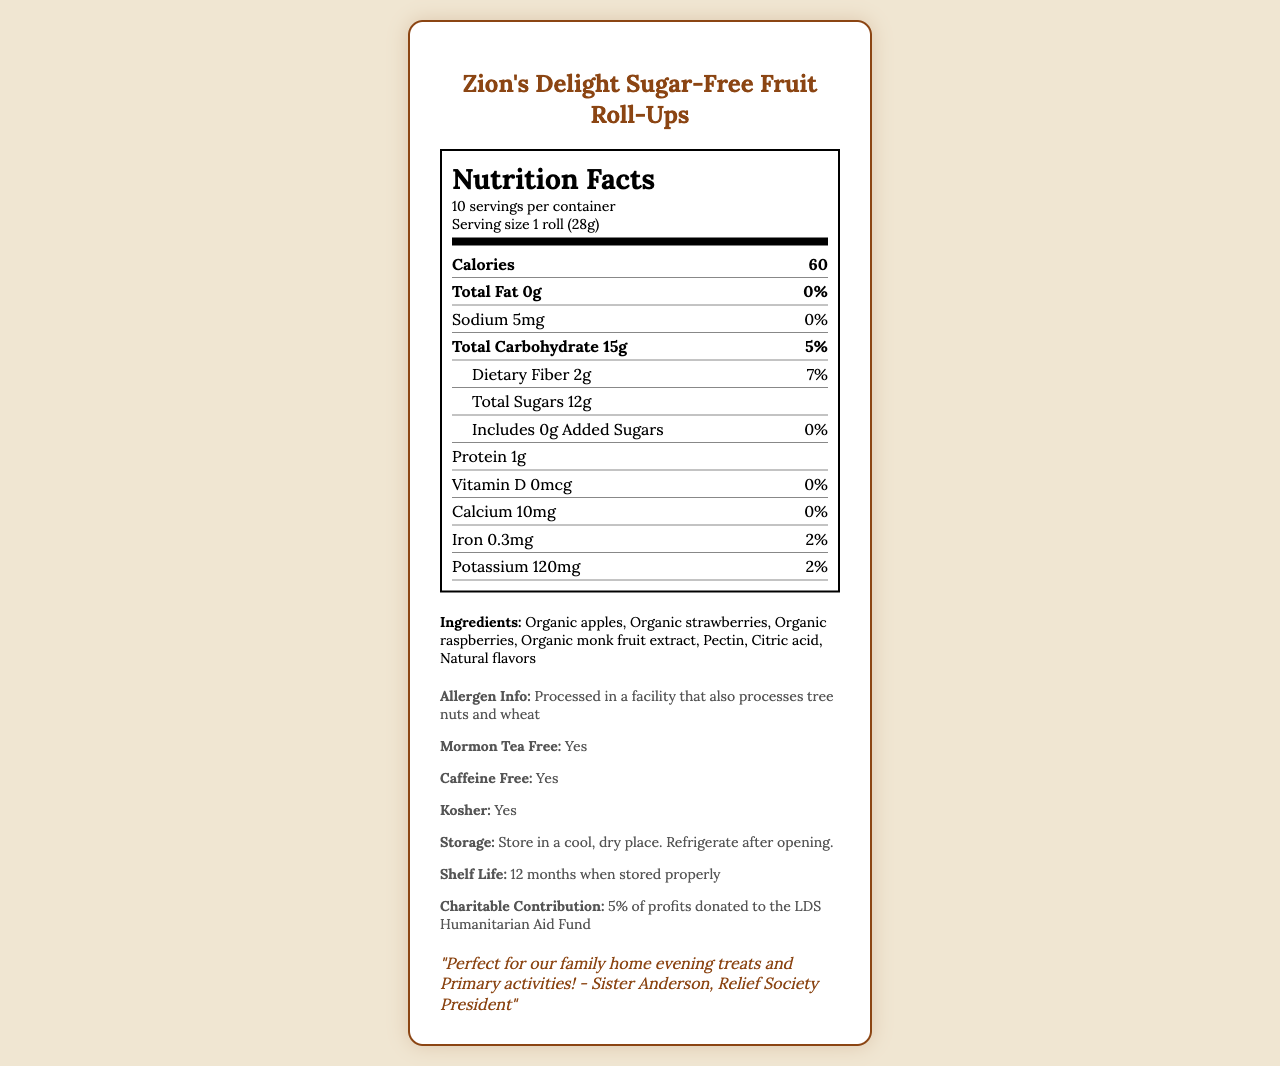what is the serving size? The serving size is indicated as "1 roll (28g)" in the serving information section.
Answer: 1 roll (28g) how many servings are there per container? The document specifies that there are 10 servings per container.
Answer: 10 what amount of dietary fiber does one serving contain? Under the “Total Carbohydrate” section, the dietary fiber amount is listed as "2g."
Answer: 2g how much iron does this product contain per serving? The listed amount for iron in the nutrition facts is "0.3mg."
Answer: 0.3mg how much potassium is in one serving? The potassium content is listed as "120mg" in the nutrition facts.
Answer: 120mg how many calories are in one serving? The "Calories" section explicitly states that one serving contains 60 calories.
Answer: 60 is this product kosher? The document indicates that the product is kosher.
Answer: Yes does the product contain added sugars? The document specifically notes that added sugars are "0g."
Answer: No pick the correct allergen information for this product:
A. Contains peanuts
B. Processed in a facility that also processes tree nuts and wheat
C. Gluten-free The allergen information section states, "Processed in a facility that also processes tree nuts and wheat."
Answer: B which of the following ingredients is not included in the product?
I. Organic apples
II. Organic strawberries
III. Sugar The ingredients list includes organic apples and strawberries but does not list sugar as an ingredient.
Answer: III is this product suitable for food storage? The additional information states that the product is suitable for food storage.
Answer: Yes how much calcium does one serving contain? The nutrition facts show that each serving contains "10mg" of calcium.
Answer: 10mg summarize the main idea of this document. The summary captures the essential details from the document, focusing on the product's nutritional content, related information, and its cultural and community relevance.
Answer: The document provides nutrition facts and additional information about Zion's Delight Sugar-Free Fruit Roll-Ups, including ingredients, serving size, allergen information, preparation and storage instructions, charitable contributions, and a testimonial specifically highlighting its suitability for Latter-day Saints family activities. who created the original recipe for Zion's Delight Sugar-Free Fruit Roll-Ups? The document notes that the recipe is inspired by Sister Johnson's family recipe from the Provo 5th Ward cookbook, but it does not provide specific details about who created the original recipe.
Answer: Not enough information 